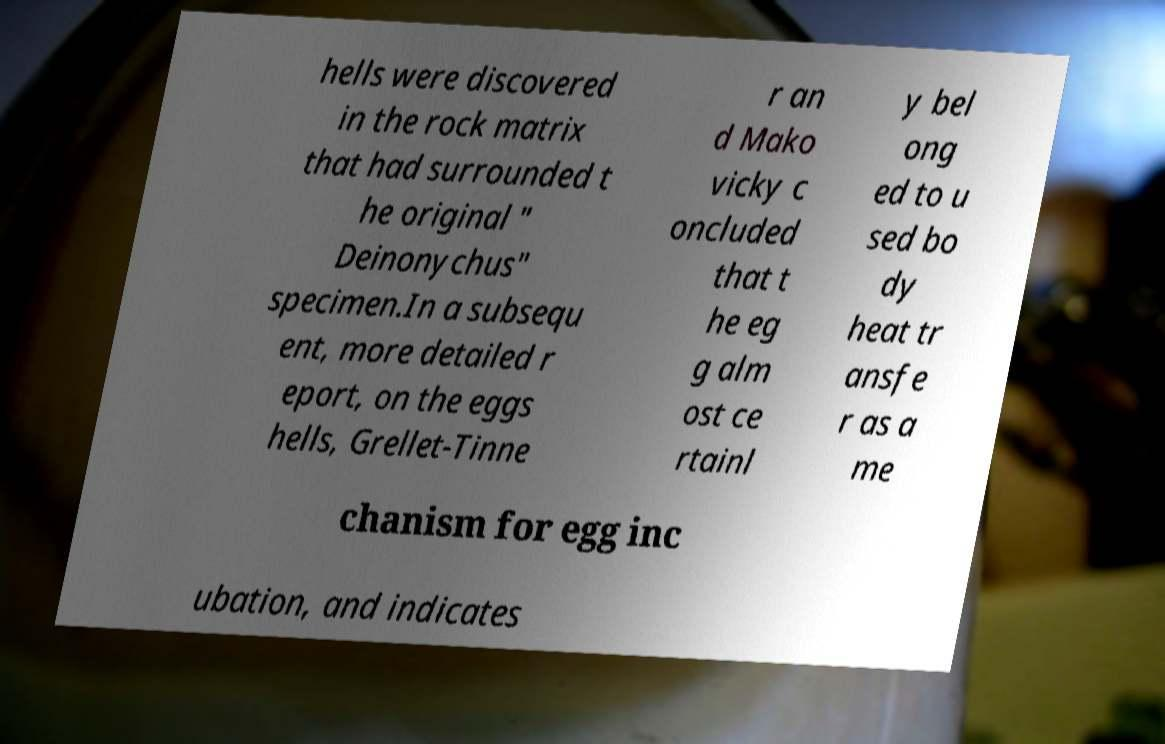Can you read and provide the text displayed in the image?This photo seems to have some interesting text. Can you extract and type it out for me? hells were discovered in the rock matrix that had surrounded t he original " Deinonychus" specimen.In a subsequ ent, more detailed r eport, on the eggs hells, Grellet-Tinne r an d Mako vicky c oncluded that t he eg g alm ost ce rtainl y bel ong ed to u sed bo dy heat tr ansfe r as a me chanism for egg inc ubation, and indicates 